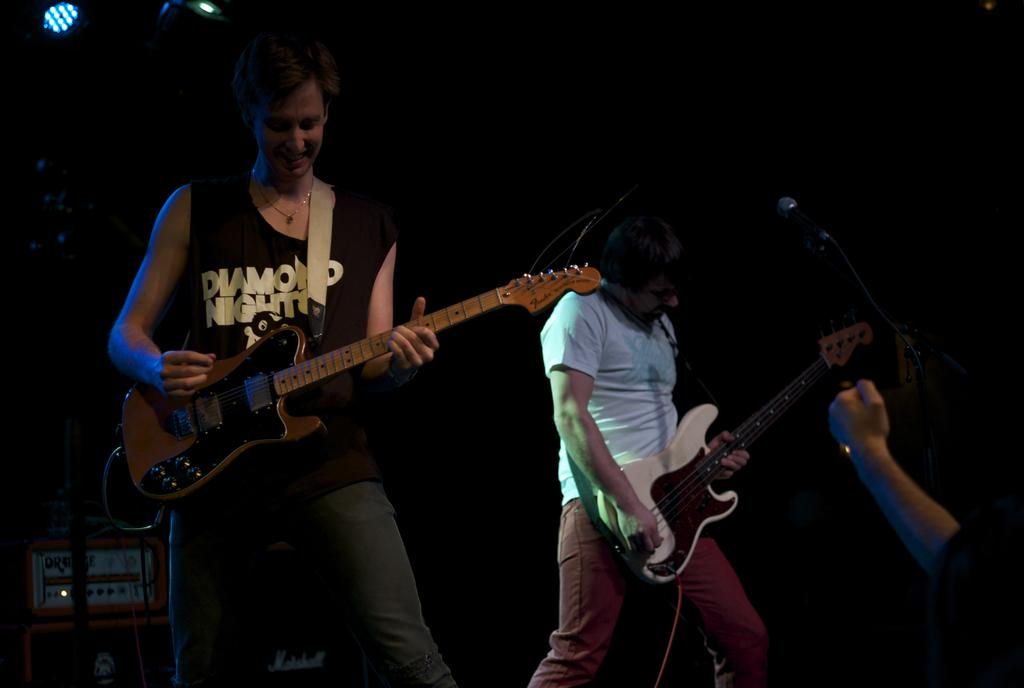How many people are in the image? There are two persons in the image. What are the two persons doing in the image? The two persons are standing and playing a guitar. What type of tub can be seen in the image? There is no tub present in the image. What color is the chalk that the persons are using to play the guitar? There is no chalk visible in the image, as the persons are playing a guitar, not drawing. 